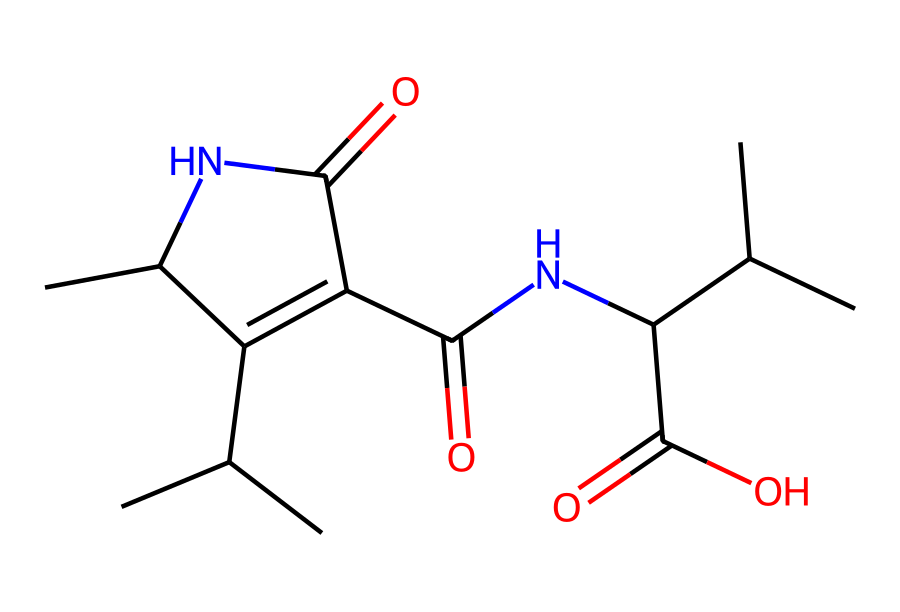How many carbon atoms are in this molecule? To determine the number of carbon atoms, we need to identify each carbon atom present in the SMILES representation. Each "C" in the SMILES corresponds to a carbon atom, and the branching and cyclic structure indicated in the SMILES must also be considered. Counting these values results in a total of 12 carbon atoms.
Answer: twelve What type of chemical structure is shown by this SMILES? The SMILES representation indicates that this chemical has multiple functional groups, primarily amides (due to the presence of nitrogen connected to carbonyl groups). Additionally, it includes both ketone and carboxylic acid functional groups. This composition suggests that it is a statin, which is known for cholesterol-lowering effects.
Answer: statin How many nitrogen atoms are present in the molecule? The presence of nitrogen in the structure can be identified by the letter "N" in the SMILES. Each "N" denotes one nitrogen atom. In this specific case, there are two occurrences of "N" in the SMILES representation.
Answer: two Is this compound a single ring structure? The arrangement of atoms shows that there is a cyclic structure present in the molecule. Specifically, the notation indicates that one of its parts is cyclic with substituents off of it, revealing that it is more complex than just a single ring structure. Thus, it contains a bicyclic arrangement rather than a simple monocyclic one.
Answer: no What is the functional group represented by the -C(=O)O portion of the molecule? The -C(=O)O part of the structure indicates a carboxylic acid functional group where carbon is double-bonded to an oxygen (carbonyl) and single bonded to a hydroxyl group (OH). This is evidenced by the specific pattern that is consistently recognized in organic chemistry.
Answer: carboxylic acid Which functional groups indicate that this compound could lower cholesterol? Statins are characterized largely by the presence of the carbonyl and amide functional groups, along with the carboxylic acid group, which participates in blocking HMG-CoA reductase in the mevalonate pathway, crucial for cholesterol production. The presence of these specific groups suggests functionality in cholesterol-lowering mechanisms.
Answer: carbonyl and amide 